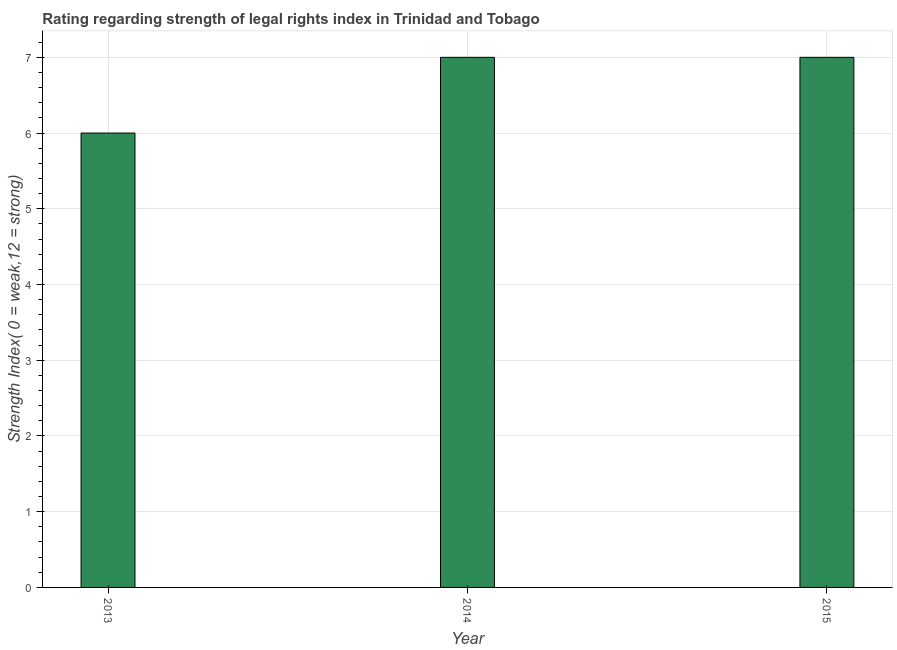Does the graph contain any zero values?
Provide a succinct answer. No. Does the graph contain grids?
Your response must be concise. Yes. What is the title of the graph?
Ensure brevity in your answer.  Rating regarding strength of legal rights index in Trinidad and Tobago. What is the label or title of the Y-axis?
Keep it short and to the point. Strength Index( 0 = weak,12 = strong). What is the strength of legal rights index in 2014?
Keep it short and to the point. 7. In which year was the strength of legal rights index maximum?
Offer a terse response. 2014. In which year was the strength of legal rights index minimum?
Ensure brevity in your answer.  2013. What is the sum of the strength of legal rights index?
Your answer should be compact. 20. What is the average strength of legal rights index per year?
Keep it short and to the point. 6. What is the median strength of legal rights index?
Provide a short and direct response. 7. Do a majority of the years between 2014 and 2013 (inclusive) have strength of legal rights index greater than 3.4 ?
Your response must be concise. No. Is the strength of legal rights index in 2013 less than that in 2015?
Provide a short and direct response. Yes. What is the difference between the highest and the second highest strength of legal rights index?
Your answer should be compact. 0. Is the sum of the strength of legal rights index in 2013 and 2014 greater than the maximum strength of legal rights index across all years?
Ensure brevity in your answer.  Yes. What is the difference between the highest and the lowest strength of legal rights index?
Your response must be concise. 1. How many bars are there?
Provide a succinct answer. 3. Are all the bars in the graph horizontal?
Your response must be concise. No. Are the values on the major ticks of Y-axis written in scientific E-notation?
Keep it short and to the point. No. What is the Strength Index( 0 = weak,12 = strong) in 2013?
Provide a short and direct response. 6. What is the Strength Index( 0 = weak,12 = strong) of 2014?
Make the answer very short. 7. What is the Strength Index( 0 = weak,12 = strong) of 2015?
Provide a succinct answer. 7. What is the difference between the Strength Index( 0 = weak,12 = strong) in 2013 and 2014?
Provide a succinct answer. -1. What is the difference between the Strength Index( 0 = weak,12 = strong) in 2013 and 2015?
Your answer should be compact. -1. What is the difference between the Strength Index( 0 = weak,12 = strong) in 2014 and 2015?
Offer a terse response. 0. What is the ratio of the Strength Index( 0 = weak,12 = strong) in 2013 to that in 2014?
Offer a terse response. 0.86. What is the ratio of the Strength Index( 0 = weak,12 = strong) in 2013 to that in 2015?
Keep it short and to the point. 0.86. 